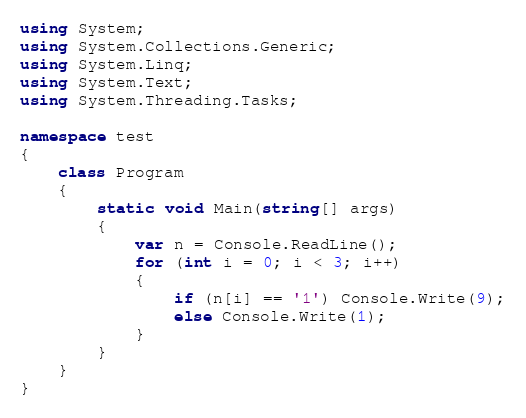Convert code to text. <code><loc_0><loc_0><loc_500><loc_500><_C#_>using System;
using System.Collections.Generic;
using System.Linq;
using System.Text;
using System.Threading.Tasks;

namespace test
{
    class Program
    {
        static void Main(string[] args)
        {
            var n = Console.ReadLine();
            for (int i = 0; i < 3; i++)
            {
                if (n[i] == '1') Console.Write(9);
                else Console.Write(1);
            }
        }
    }
}</code> 